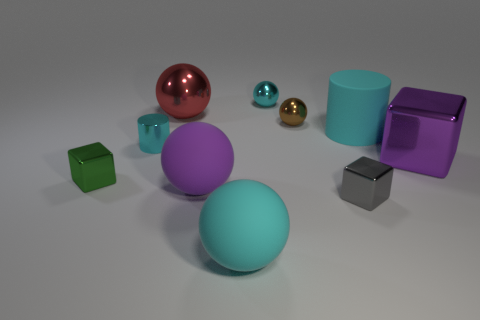How many cyan cylinders must be subtracted to get 1 cyan cylinders? 1 Subtract all green blocks. How many cyan balls are left? 2 Subtract all tiny cyan shiny spheres. How many spheres are left? 4 Subtract 1 balls. How many balls are left? 4 Subtract all cyan balls. How many balls are left? 3 Add 8 tiny purple matte balls. How many tiny purple matte balls exist? 8 Subtract 1 purple spheres. How many objects are left? 9 Subtract all cubes. How many objects are left? 7 Subtract all red cubes. Subtract all yellow cylinders. How many cubes are left? 3 Subtract all purple rubber things. Subtract all cyan metal cylinders. How many objects are left? 8 